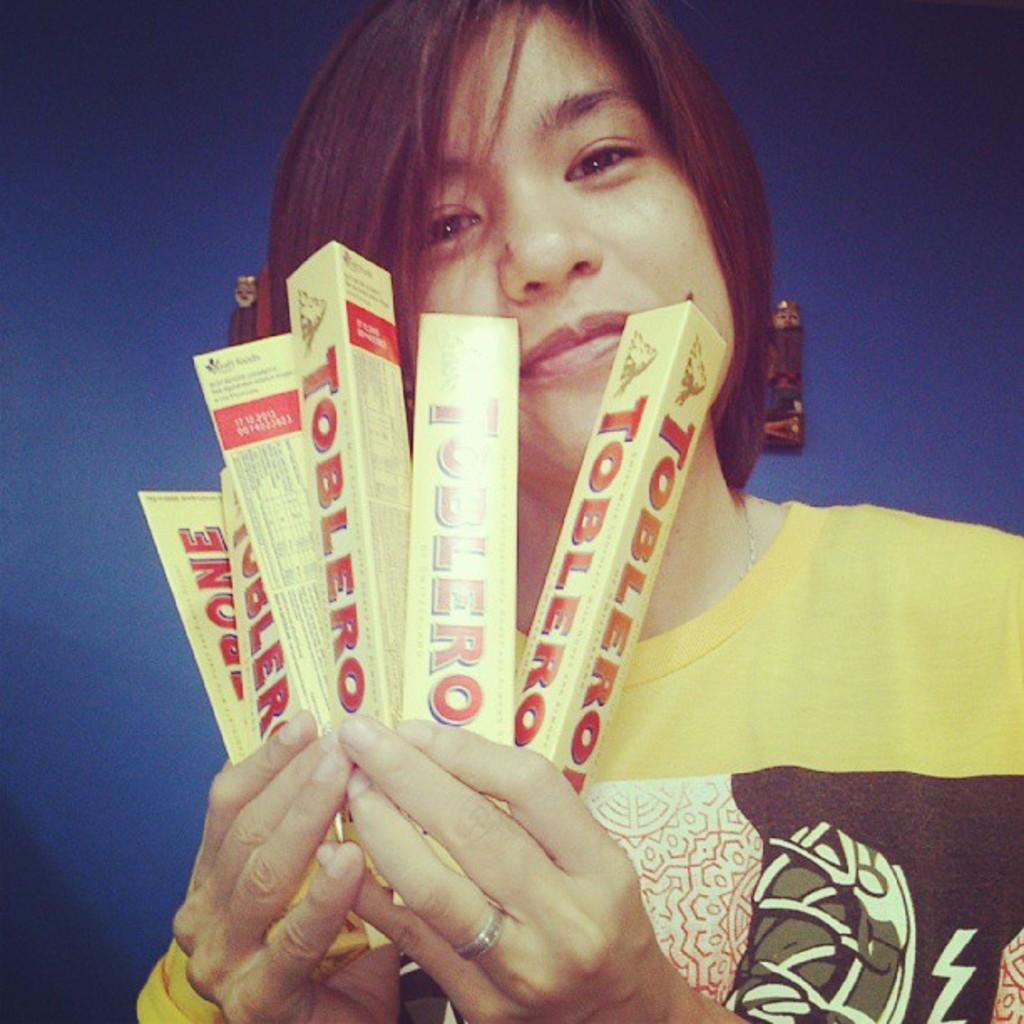What is the main subject of the image? There is a person in the image. What is the person doing in the image? The person is watching and holding objects. What is the person's facial expression in the image? The person is smiling. What color is the background of the image? The background of the image is blue. What can be seen in the background of the image? There are objects visible in the background. What type of yarn is the person using in the image? There is no yarn present in the image. --- Facts: 1. There is a person in the image. 2. The person is holding a book. 3. The person is sitting on a chair. 4. The person is wearing glasses. 5. The background of the image is a library. Absurd Topics: elephant, piano Conversation: Who or what is the main subject of the image? The main subject of the image is a person. What is the person in the image doing? The person in the image is holding a book. What is the person's posture in the image? The person in the image is sitting on a chair. What is the person wearing in the image? The person in the image is wearing glasses. What can be seen in the background of the image? The background of the image is a library. Reasoning: Let's think step by step in order to produce the conversation. We start by identifying the main subject of the image, which is the person. Then, we describe the person's actions and posture, as well as any accessories they are wearing. Next, we describe the background of the image, which is a library. Each question is designed to elicit a specific detail about the image that is known from the provided facts. Absurd Question/Answer: Can you hear the elephant playing the piano in the background of the image? There is no elephant or piano present in the image; it is a person sitting in a library holding a book. 